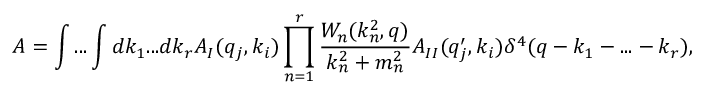<formula> <loc_0><loc_0><loc_500><loc_500>A = \int \dots \int d k _ { 1 } \dots d k _ { r } A _ { I } ( q _ { j } , k _ { i } ) \prod _ { n = 1 } ^ { r } \frac { W _ { n } ( k _ { n } ^ { 2 } , q ) } { k _ { n } ^ { 2 } + m _ { n } ^ { 2 } } A _ { I I } ( q _ { j } ^ { \prime } , k _ { i } ) \delta ^ { 4 } ( q - k _ { 1 } - \dots - k _ { r } ) ,</formula> 